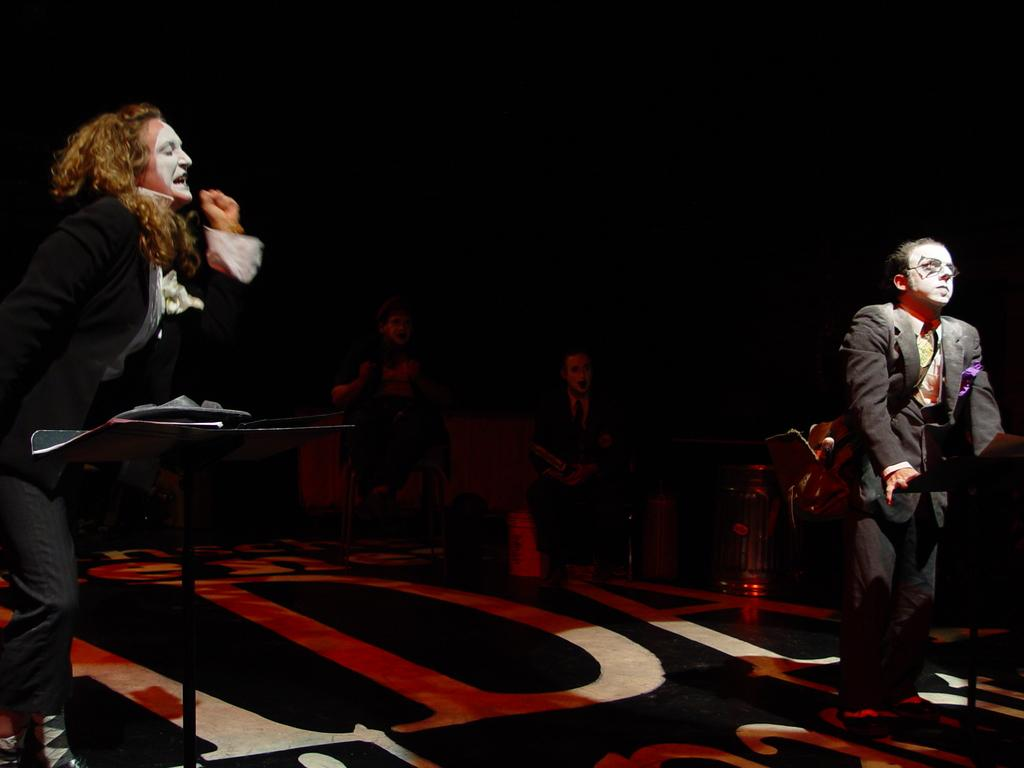How many people are visible in the image? There are two persons on the sides of the image and two persons sitting in the back, making a total of four people visible. What is located on the left side of the image? There is a stand on the left side of the image. Can you describe the seating arrangement in the image? There are two persons sitting in the back of the image. What can be seen in the image besides the people and the stand? There are some items in the image. What is the color of the background in the image? The background of the image is dark. What type of nose can be seen on the giant in the image? There are no giants present in the image, so there is no nose to describe. What type of lettuce is being used as a tablecloth in the image? There is no lettuce present in the image, and it is not being used as a tablecloth. 